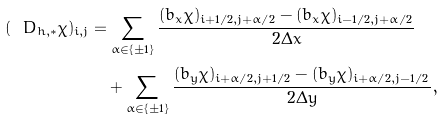Convert formula to latex. <formula><loc_0><loc_0><loc_500><loc_500>( \ D _ { h , * } \chi ) _ { i , j } & = \sum _ { \alpha \in \{ \pm 1 \} } \cfrac { ( b _ { x } \chi ) _ { i + 1 / 2 , j + \alpha / 2 } - ( b _ { x } \chi ) _ { i - 1 / 2 , j + \alpha / 2 } } { 2 \Delta x } \\ & \quad + \sum _ { \alpha \in \{ \pm 1 \} } \cfrac { ( b _ { y } \chi ) _ { i + \alpha / 2 , j + 1 / 2 } - ( b _ { y } \chi ) _ { i + \alpha / 2 , j - 1 / 2 } } { 2 \Delta y } \, ,</formula> 